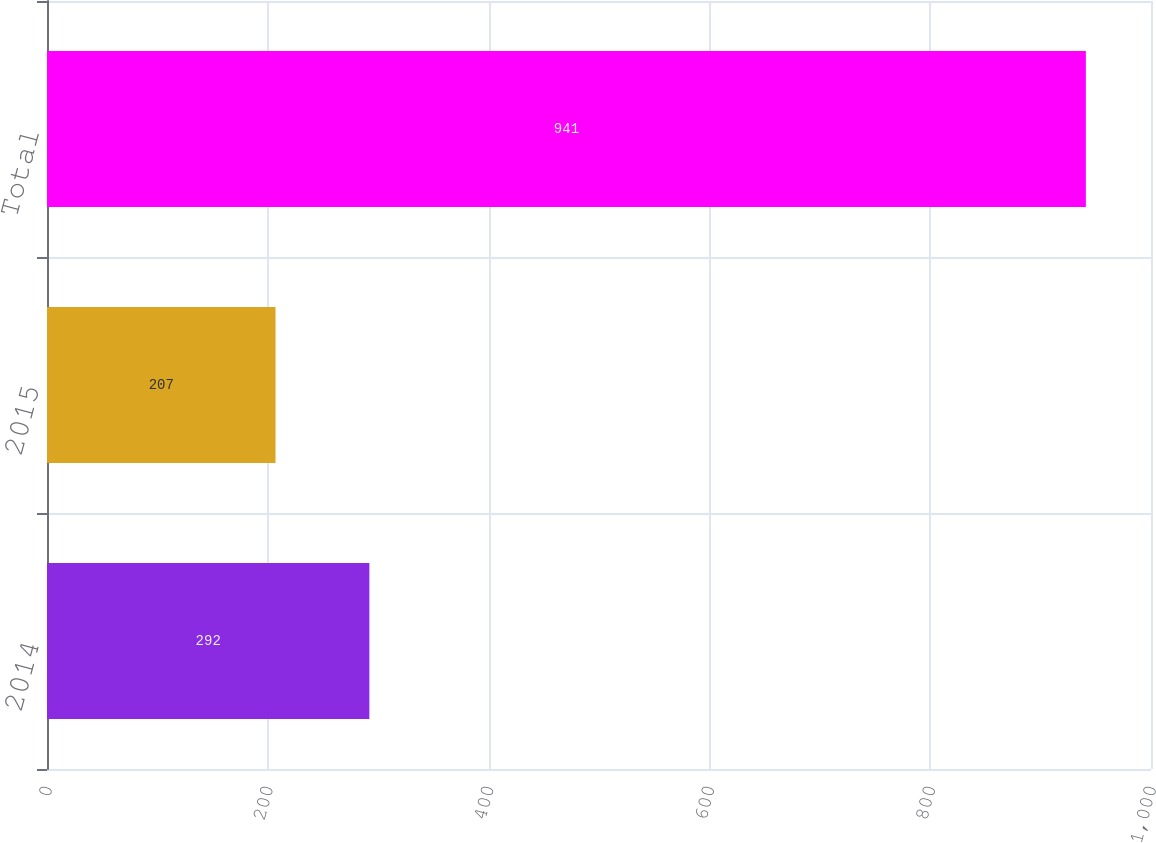Convert chart. <chart><loc_0><loc_0><loc_500><loc_500><bar_chart><fcel>2014<fcel>2015<fcel>Total<nl><fcel>292<fcel>207<fcel>941<nl></chart> 